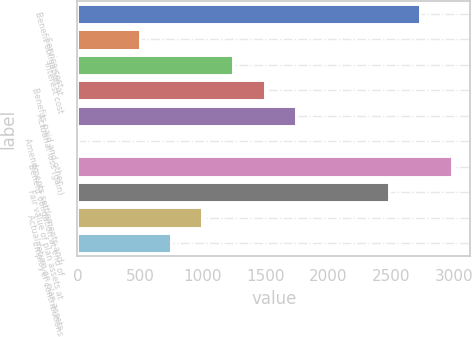<chart> <loc_0><loc_0><loc_500><loc_500><bar_chart><fcel>Benefit obligation at<fcel>Service cost<fcel>Interest cost<fcel>Benefits paid and other<fcel>Actuarial loss (gain)<fcel>Amendments settlements and<fcel>Benefit obligation at end of<fcel>Fair value of plan assets at<fcel>Actual return on plan assets<fcel>Employer contributions<nl><fcel>2733.02<fcel>498.14<fcel>1243.1<fcel>1491.42<fcel>1739.74<fcel>1.5<fcel>2981.34<fcel>2484.7<fcel>994.78<fcel>746.46<nl></chart> 